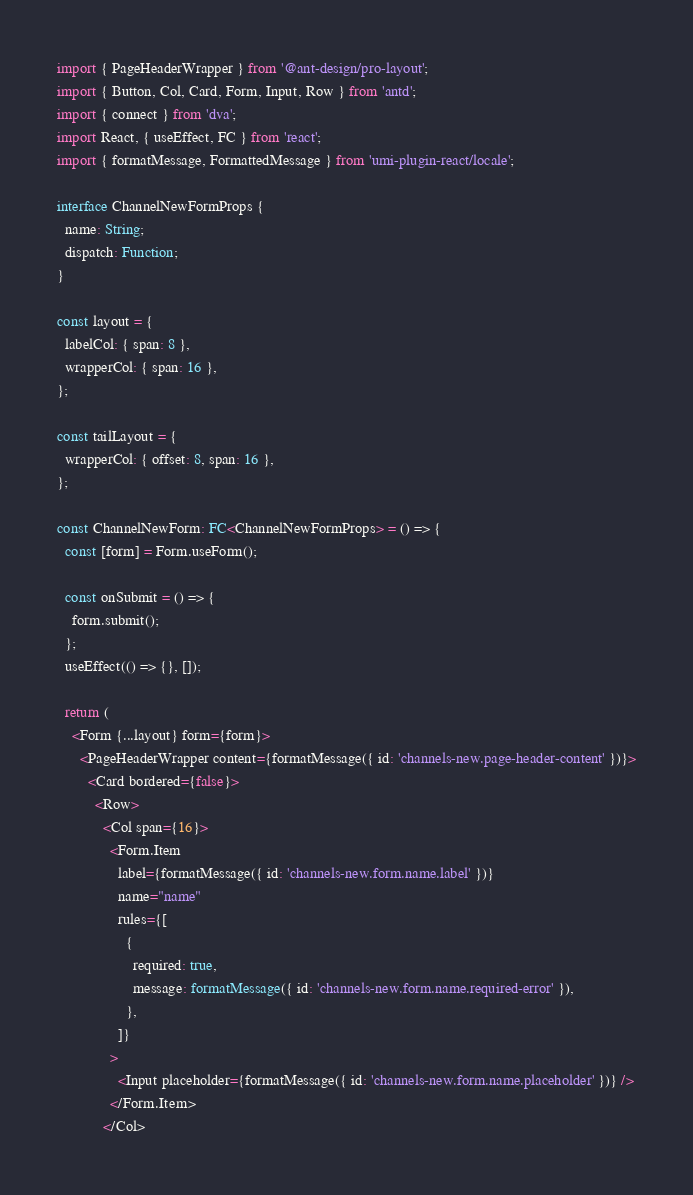<code> <loc_0><loc_0><loc_500><loc_500><_TypeScript_>import { PageHeaderWrapper } from '@ant-design/pro-layout';
import { Button, Col, Card, Form, Input, Row } from 'antd';
import { connect } from 'dva';
import React, { useEffect, FC } from 'react';
import { formatMessage, FormattedMessage } from 'umi-plugin-react/locale';

interface ChannelNewFormProps {
  name: String;
  dispatch: Function;
}

const layout = {
  labelCol: { span: 8 },
  wrapperCol: { span: 16 },
};

const tailLayout = {
  wrapperCol: { offset: 8, span: 16 },
};

const ChannelNewForm: FC<ChannelNewFormProps> = () => {
  const [form] = Form.useForm();

  const onSubmit = () => {
    form.submit();
  };
  useEffect(() => {}, []);

  return (
    <Form {...layout} form={form}>
      <PageHeaderWrapper content={formatMessage({ id: 'channels-new.page-header-content' })}>
        <Card bordered={false}>
          <Row>
            <Col span={16}>
              <Form.Item
                label={formatMessage({ id: 'channels-new.form.name.label' })}
                name="name"
                rules={[
                  {
                    required: true,
                    message: formatMessage({ id: 'channels-new.form.name.required-error' }),
                  },
                ]}
              >
                <Input placeholder={formatMessage({ id: 'channels-new.form.name.placeholder' })} />
              </Form.Item>
            </Col></code> 